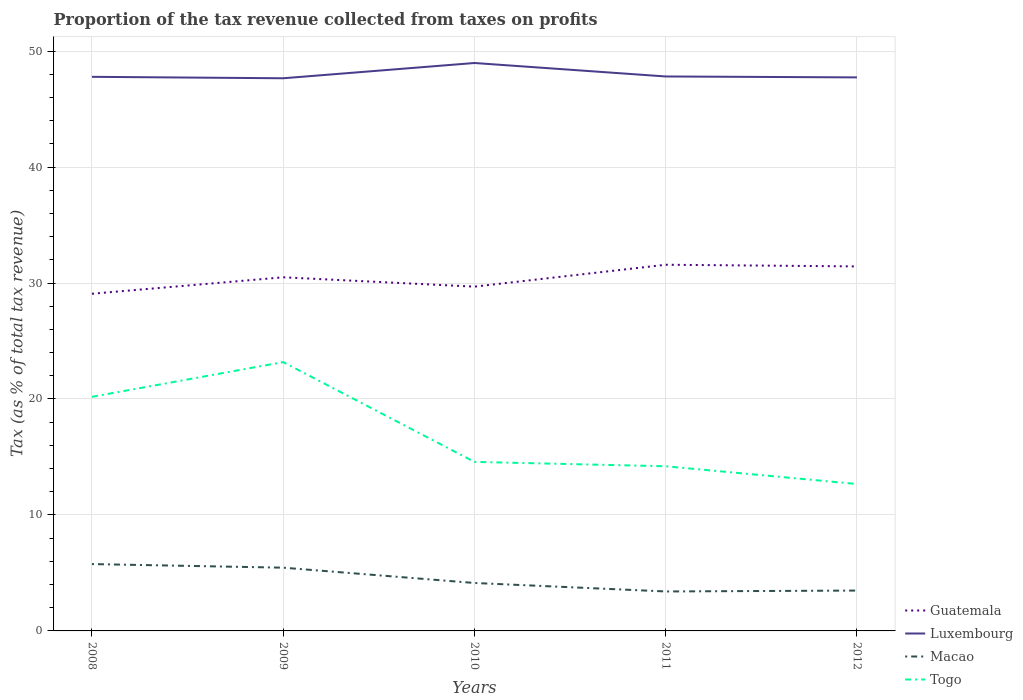Is the number of lines equal to the number of legend labels?
Provide a short and direct response. Yes. Across all years, what is the maximum proportion of the tax revenue collected in Luxembourg?
Provide a succinct answer. 47.66. In which year was the proportion of the tax revenue collected in Guatemala maximum?
Your response must be concise. 2008. What is the total proportion of the tax revenue collected in Togo in the graph?
Your answer should be very brief. 1.91. What is the difference between the highest and the second highest proportion of the tax revenue collected in Guatemala?
Keep it short and to the point. 2.5. Are the values on the major ticks of Y-axis written in scientific E-notation?
Your response must be concise. No. Does the graph contain grids?
Give a very brief answer. Yes. How many legend labels are there?
Provide a succinct answer. 4. What is the title of the graph?
Make the answer very short. Proportion of the tax revenue collected from taxes on profits. What is the label or title of the X-axis?
Provide a short and direct response. Years. What is the label or title of the Y-axis?
Make the answer very short. Tax (as % of total tax revenue). What is the Tax (as % of total tax revenue) in Guatemala in 2008?
Keep it short and to the point. 29.08. What is the Tax (as % of total tax revenue) of Luxembourg in 2008?
Offer a terse response. 47.78. What is the Tax (as % of total tax revenue) of Macao in 2008?
Provide a short and direct response. 5.76. What is the Tax (as % of total tax revenue) of Togo in 2008?
Keep it short and to the point. 20.19. What is the Tax (as % of total tax revenue) in Guatemala in 2009?
Your response must be concise. 30.49. What is the Tax (as % of total tax revenue) of Luxembourg in 2009?
Provide a short and direct response. 47.66. What is the Tax (as % of total tax revenue) of Macao in 2009?
Give a very brief answer. 5.45. What is the Tax (as % of total tax revenue) in Togo in 2009?
Keep it short and to the point. 23.18. What is the Tax (as % of total tax revenue) of Guatemala in 2010?
Your response must be concise. 29.69. What is the Tax (as % of total tax revenue) of Luxembourg in 2010?
Your answer should be very brief. 48.97. What is the Tax (as % of total tax revenue) of Macao in 2010?
Keep it short and to the point. 4.13. What is the Tax (as % of total tax revenue) of Togo in 2010?
Make the answer very short. 14.58. What is the Tax (as % of total tax revenue) of Guatemala in 2011?
Offer a terse response. 31.58. What is the Tax (as % of total tax revenue) of Luxembourg in 2011?
Offer a terse response. 47.81. What is the Tax (as % of total tax revenue) in Macao in 2011?
Provide a short and direct response. 3.4. What is the Tax (as % of total tax revenue) in Togo in 2011?
Your response must be concise. 14.2. What is the Tax (as % of total tax revenue) in Guatemala in 2012?
Your answer should be very brief. 31.43. What is the Tax (as % of total tax revenue) in Luxembourg in 2012?
Offer a terse response. 47.73. What is the Tax (as % of total tax revenue) of Macao in 2012?
Give a very brief answer. 3.48. What is the Tax (as % of total tax revenue) in Togo in 2012?
Your answer should be compact. 12.67. Across all years, what is the maximum Tax (as % of total tax revenue) in Guatemala?
Make the answer very short. 31.58. Across all years, what is the maximum Tax (as % of total tax revenue) in Luxembourg?
Offer a terse response. 48.97. Across all years, what is the maximum Tax (as % of total tax revenue) of Macao?
Make the answer very short. 5.76. Across all years, what is the maximum Tax (as % of total tax revenue) in Togo?
Make the answer very short. 23.18. Across all years, what is the minimum Tax (as % of total tax revenue) in Guatemala?
Provide a short and direct response. 29.08. Across all years, what is the minimum Tax (as % of total tax revenue) of Luxembourg?
Keep it short and to the point. 47.66. Across all years, what is the minimum Tax (as % of total tax revenue) of Macao?
Keep it short and to the point. 3.4. Across all years, what is the minimum Tax (as % of total tax revenue) of Togo?
Ensure brevity in your answer.  12.67. What is the total Tax (as % of total tax revenue) in Guatemala in the graph?
Ensure brevity in your answer.  152.26. What is the total Tax (as % of total tax revenue) of Luxembourg in the graph?
Give a very brief answer. 239.95. What is the total Tax (as % of total tax revenue) in Macao in the graph?
Your response must be concise. 22.23. What is the total Tax (as % of total tax revenue) of Togo in the graph?
Your answer should be compact. 84.81. What is the difference between the Tax (as % of total tax revenue) of Guatemala in 2008 and that in 2009?
Make the answer very short. -1.42. What is the difference between the Tax (as % of total tax revenue) in Luxembourg in 2008 and that in 2009?
Your answer should be compact. 0.12. What is the difference between the Tax (as % of total tax revenue) in Macao in 2008 and that in 2009?
Your response must be concise. 0.31. What is the difference between the Tax (as % of total tax revenue) of Togo in 2008 and that in 2009?
Ensure brevity in your answer.  -2.99. What is the difference between the Tax (as % of total tax revenue) of Guatemala in 2008 and that in 2010?
Your answer should be very brief. -0.61. What is the difference between the Tax (as % of total tax revenue) in Luxembourg in 2008 and that in 2010?
Give a very brief answer. -1.19. What is the difference between the Tax (as % of total tax revenue) of Macao in 2008 and that in 2010?
Your answer should be very brief. 1.63. What is the difference between the Tax (as % of total tax revenue) in Togo in 2008 and that in 2010?
Your answer should be very brief. 5.61. What is the difference between the Tax (as % of total tax revenue) in Luxembourg in 2008 and that in 2011?
Offer a terse response. -0.03. What is the difference between the Tax (as % of total tax revenue) in Macao in 2008 and that in 2011?
Your answer should be very brief. 2.36. What is the difference between the Tax (as % of total tax revenue) in Togo in 2008 and that in 2011?
Give a very brief answer. 5.99. What is the difference between the Tax (as % of total tax revenue) in Guatemala in 2008 and that in 2012?
Make the answer very short. -2.36. What is the difference between the Tax (as % of total tax revenue) of Luxembourg in 2008 and that in 2012?
Give a very brief answer. 0.05. What is the difference between the Tax (as % of total tax revenue) in Macao in 2008 and that in 2012?
Offer a terse response. 2.28. What is the difference between the Tax (as % of total tax revenue) in Togo in 2008 and that in 2012?
Ensure brevity in your answer.  7.52. What is the difference between the Tax (as % of total tax revenue) in Guatemala in 2009 and that in 2010?
Your response must be concise. 0.81. What is the difference between the Tax (as % of total tax revenue) of Luxembourg in 2009 and that in 2010?
Keep it short and to the point. -1.32. What is the difference between the Tax (as % of total tax revenue) of Macao in 2009 and that in 2010?
Your answer should be very brief. 1.32. What is the difference between the Tax (as % of total tax revenue) of Togo in 2009 and that in 2010?
Your answer should be compact. 8.61. What is the difference between the Tax (as % of total tax revenue) in Guatemala in 2009 and that in 2011?
Your response must be concise. -1.08. What is the difference between the Tax (as % of total tax revenue) in Luxembourg in 2009 and that in 2011?
Provide a succinct answer. -0.15. What is the difference between the Tax (as % of total tax revenue) of Macao in 2009 and that in 2011?
Your response must be concise. 2.05. What is the difference between the Tax (as % of total tax revenue) of Togo in 2009 and that in 2011?
Ensure brevity in your answer.  8.98. What is the difference between the Tax (as % of total tax revenue) of Guatemala in 2009 and that in 2012?
Keep it short and to the point. -0.94. What is the difference between the Tax (as % of total tax revenue) in Luxembourg in 2009 and that in 2012?
Offer a terse response. -0.08. What is the difference between the Tax (as % of total tax revenue) of Macao in 2009 and that in 2012?
Provide a succinct answer. 1.97. What is the difference between the Tax (as % of total tax revenue) of Togo in 2009 and that in 2012?
Provide a succinct answer. 10.51. What is the difference between the Tax (as % of total tax revenue) of Guatemala in 2010 and that in 2011?
Ensure brevity in your answer.  -1.89. What is the difference between the Tax (as % of total tax revenue) of Luxembourg in 2010 and that in 2011?
Make the answer very short. 1.16. What is the difference between the Tax (as % of total tax revenue) of Macao in 2010 and that in 2011?
Your response must be concise. 0.73. What is the difference between the Tax (as % of total tax revenue) in Togo in 2010 and that in 2011?
Your response must be concise. 0.38. What is the difference between the Tax (as % of total tax revenue) of Guatemala in 2010 and that in 2012?
Your answer should be compact. -1.74. What is the difference between the Tax (as % of total tax revenue) in Luxembourg in 2010 and that in 2012?
Your response must be concise. 1.24. What is the difference between the Tax (as % of total tax revenue) of Macao in 2010 and that in 2012?
Your answer should be very brief. 0.65. What is the difference between the Tax (as % of total tax revenue) in Togo in 2010 and that in 2012?
Provide a succinct answer. 1.91. What is the difference between the Tax (as % of total tax revenue) of Guatemala in 2011 and that in 2012?
Ensure brevity in your answer.  0.14. What is the difference between the Tax (as % of total tax revenue) in Luxembourg in 2011 and that in 2012?
Provide a succinct answer. 0.08. What is the difference between the Tax (as % of total tax revenue) of Macao in 2011 and that in 2012?
Keep it short and to the point. -0.08. What is the difference between the Tax (as % of total tax revenue) in Togo in 2011 and that in 2012?
Your answer should be compact. 1.53. What is the difference between the Tax (as % of total tax revenue) in Guatemala in 2008 and the Tax (as % of total tax revenue) in Luxembourg in 2009?
Make the answer very short. -18.58. What is the difference between the Tax (as % of total tax revenue) in Guatemala in 2008 and the Tax (as % of total tax revenue) in Macao in 2009?
Provide a short and direct response. 23.62. What is the difference between the Tax (as % of total tax revenue) of Guatemala in 2008 and the Tax (as % of total tax revenue) of Togo in 2009?
Provide a succinct answer. 5.89. What is the difference between the Tax (as % of total tax revenue) in Luxembourg in 2008 and the Tax (as % of total tax revenue) in Macao in 2009?
Provide a short and direct response. 42.33. What is the difference between the Tax (as % of total tax revenue) in Luxembourg in 2008 and the Tax (as % of total tax revenue) in Togo in 2009?
Your answer should be very brief. 24.6. What is the difference between the Tax (as % of total tax revenue) of Macao in 2008 and the Tax (as % of total tax revenue) of Togo in 2009?
Your answer should be compact. -17.42. What is the difference between the Tax (as % of total tax revenue) of Guatemala in 2008 and the Tax (as % of total tax revenue) of Luxembourg in 2010?
Ensure brevity in your answer.  -19.9. What is the difference between the Tax (as % of total tax revenue) in Guatemala in 2008 and the Tax (as % of total tax revenue) in Macao in 2010?
Ensure brevity in your answer.  24.94. What is the difference between the Tax (as % of total tax revenue) in Guatemala in 2008 and the Tax (as % of total tax revenue) in Togo in 2010?
Provide a short and direct response. 14.5. What is the difference between the Tax (as % of total tax revenue) of Luxembourg in 2008 and the Tax (as % of total tax revenue) of Macao in 2010?
Your answer should be very brief. 43.65. What is the difference between the Tax (as % of total tax revenue) in Luxembourg in 2008 and the Tax (as % of total tax revenue) in Togo in 2010?
Provide a short and direct response. 33.2. What is the difference between the Tax (as % of total tax revenue) of Macao in 2008 and the Tax (as % of total tax revenue) of Togo in 2010?
Make the answer very short. -8.81. What is the difference between the Tax (as % of total tax revenue) of Guatemala in 2008 and the Tax (as % of total tax revenue) of Luxembourg in 2011?
Ensure brevity in your answer.  -18.73. What is the difference between the Tax (as % of total tax revenue) of Guatemala in 2008 and the Tax (as % of total tax revenue) of Macao in 2011?
Offer a very short reply. 25.67. What is the difference between the Tax (as % of total tax revenue) of Guatemala in 2008 and the Tax (as % of total tax revenue) of Togo in 2011?
Your response must be concise. 14.88. What is the difference between the Tax (as % of total tax revenue) in Luxembourg in 2008 and the Tax (as % of total tax revenue) in Macao in 2011?
Provide a short and direct response. 44.38. What is the difference between the Tax (as % of total tax revenue) of Luxembourg in 2008 and the Tax (as % of total tax revenue) of Togo in 2011?
Offer a very short reply. 33.58. What is the difference between the Tax (as % of total tax revenue) in Macao in 2008 and the Tax (as % of total tax revenue) in Togo in 2011?
Your response must be concise. -8.43. What is the difference between the Tax (as % of total tax revenue) in Guatemala in 2008 and the Tax (as % of total tax revenue) in Luxembourg in 2012?
Give a very brief answer. -18.66. What is the difference between the Tax (as % of total tax revenue) in Guatemala in 2008 and the Tax (as % of total tax revenue) in Macao in 2012?
Make the answer very short. 25.6. What is the difference between the Tax (as % of total tax revenue) in Guatemala in 2008 and the Tax (as % of total tax revenue) in Togo in 2012?
Ensure brevity in your answer.  16.41. What is the difference between the Tax (as % of total tax revenue) of Luxembourg in 2008 and the Tax (as % of total tax revenue) of Macao in 2012?
Give a very brief answer. 44.3. What is the difference between the Tax (as % of total tax revenue) of Luxembourg in 2008 and the Tax (as % of total tax revenue) of Togo in 2012?
Give a very brief answer. 35.11. What is the difference between the Tax (as % of total tax revenue) in Macao in 2008 and the Tax (as % of total tax revenue) in Togo in 2012?
Offer a terse response. -6.9. What is the difference between the Tax (as % of total tax revenue) in Guatemala in 2009 and the Tax (as % of total tax revenue) in Luxembourg in 2010?
Your response must be concise. -18.48. What is the difference between the Tax (as % of total tax revenue) of Guatemala in 2009 and the Tax (as % of total tax revenue) of Macao in 2010?
Provide a short and direct response. 26.36. What is the difference between the Tax (as % of total tax revenue) of Guatemala in 2009 and the Tax (as % of total tax revenue) of Togo in 2010?
Offer a terse response. 15.92. What is the difference between the Tax (as % of total tax revenue) in Luxembourg in 2009 and the Tax (as % of total tax revenue) in Macao in 2010?
Keep it short and to the point. 43.52. What is the difference between the Tax (as % of total tax revenue) of Luxembourg in 2009 and the Tax (as % of total tax revenue) of Togo in 2010?
Keep it short and to the point. 33.08. What is the difference between the Tax (as % of total tax revenue) in Macao in 2009 and the Tax (as % of total tax revenue) in Togo in 2010?
Offer a very short reply. -9.12. What is the difference between the Tax (as % of total tax revenue) of Guatemala in 2009 and the Tax (as % of total tax revenue) of Luxembourg in 2011?
Ensure brevity in your answer.  -17.32. What is the difference between the Tax (as % of total tax revenue) in Guatemala in 2009 and the Tax (as % of total tax revenue) in Macao in 2011?
Provide a succinct answer. 27.09. What is the difference between the Tax (as % of total tax revenue) of Guatemala in 2009 and the Tax (as % of total tax revenue) of Togo in 2011?
Offer a very short reply. 16.29. What is the difference between the Tax (as % of total tax revenue) of Luxembourg in 2009 and the Tax (as % of total tax revenue) of Macao in 2011?
Ensure brevity in your answer.  44.25. What is the difference between the Tax (as % of total tax revenue) of Luxembourg in 2009 and the Tax (as % of total tax revenue) of Togo in 2011?
Provide a short and direct response. 33.46. What is the difference between the Tax (as % of total tax revenue) of Macao in 2009 and the Tax (as % of total tax revenue) of Togo in 2011?
Ensure brevity in your answer.  -8.74. What is the difference between the Tax (as % of total tax revenue) of Guatemala in 2009 and the Tax (as % of total tax revenue) of Luxembourg in 2012?
Your response must be concise. -17.24. What is the difference between the Tax (as % of total tax revenue) of Guatemala in 2009 and the Tax (as % of total tax revenue) of Macao in 2012?
Provide a succinct answer. 27.01. What is the difference between the Tax (as % of total tax revenue) of Guatemala in 2009 and the Tax (as % of total tax revenue) of Togo in 2012?
Keep it short and to the point. 17.82. What is the difference between the Tax (as % of total tax revenue) in Luxembourg in 2009 and the Tax (as % of total tax revenue) in Macao in 2012?
Keep it short and to the point. 44.18. What is the difference between the Tax (as % of total tax revenue) in Luxembourg in 2009 and the Tax (as % of total tax revenue) in Togo in 2012?
Provide a short and direct response. 34.99. What is the difference between the Tax (as % of total tax revenue) in Macao in 2009 and the Tax (as % of total tax revenue) in Togo in 2012?
Provide a short and direct response. -7.22. What is the difference between the Tax (as % of total tax revenue) in Guatemala in 2010 and the Tax (as % of total tax revenue) in Luxembourg in 2011?
Ensure brevity in your answer.  -18.12. What is the difference between the Tax (as % of total tax revenue) of Guatemala in 2010 and the Tax (as % of total tax revenue) of Macao in 2011?
Give a very brief answer. 26.29. What is the difference between the Tax (as % of total tax revenue) in Guatemala in 2010 and the Tax (as % of total tax revenue) in Togo in 2011?
Offer a very short reply. 15.49. What is the difference between the Tax (as % of total tax revenue) of Luxembourg in 2010 and the Tax (as % of total tax revenue) of Macao in 2011?
Ensure brevity in your answer.  45.57. What is the difference between the Tax (as % of total tax revenue) in Luxembourg in 2010 and the Tax (as % of total tax revenue) in Togo in 2011?
Make the answer very short. 34.77. What is the difference between the Tax (as % of total tax revenue) of Macao in 2010 and the Tax (as % of total tax revenue) of Togo in 2011?
Your answer should be compact. -10.06. What is the difference between the Tax (as % of total tax revenue) of Guatemala in 2010 and the Tax (as % of total tax revenue) of Luxembourg in 2012?
Provide a succinct answer. -18.04. What is the difference between the Tax (as % of total tax revenue) of Guatemala in 2010 and the Tax (as % of total tax revenue) of Macao in 2012?
Provide a short and direct response. 26.21. What is the difference between the Tax (as % of total tax revenue) in Guatemala in 2010 and the Tax (as % of total tax revenue) in Togo in 2012?
Ensure brevity in your answer.  17.02. What is the difference between the Tax (as % of total tax revenue) in Luxembourg in 2010 and the Tax (as % of total tax revenue) in Macao in 2012?
Offer a very short reply. 45.49. What is the difference between the Tax (as % of total tax revenue) of Luxembourg in 2010 and the Tax (as % of total tax revenue) of Togo in 2012?
Offer a very short reply. 36.3. What is the difference between the Tax (as % of total tax revenue) of Macao in 2010 and the Tax (as % of total tax revenue) of Togo in 2012?
Offer a terse response. -8.53. What is the difference between the Tax (as % of total tax revenue) in Guatemala in 2011 and the Tax (as % of total tax revenue) in Luxembourg in 2012?
Your answer should be compact. -16.16. What is the difference between the Tax (as % of total tax revenue) of Guatemala in 2011 and the Tax (as % of total tax revenue) of Macao in 2012?
Offer a very short reply. 28.1. What is the difference between the Tax (as % of total tax revenue) in Guatemala in 2011 and the Tax (as % of total tax revenue) in Togo in 2012?
Offer a very short reply. 18.91. What is the difference between the Tax (as % of total tax revenue) of Luxembourg in 2011 and the Tax (as % of total tax revenue) of Macao in 2012?
Make the answer very short. 44.33. What is the difference between the Tax (as % of total tax revenue) in Luxembourg in 2011 and the Tax (as % of total tax revenue) in Togo in 2012?
Make the answer very short. 35.14. What is the difference between the Tax (as % of total tax revenue) in Macao in 2011 and the Tax (as % of total tax revenue) in Togo in 2012?
Provide a short and direct response. -9.27. What is the average Tax (as % of total tax revenue) in Guatemala per year?
Offer a very short reply. 30.45. What is the average Tax (as % of total tax revenue) of Luxembourg per year?
Offer a terse response. 47.99. What is the average Tax (as % of total tax revenue) of Macao per year?
Offer a terse response. 4.45. What is the average Tax (as % of total tax revenue) in Togo per year?
Make the answer very short. 16.96. In the year 2008, what is the difference between the Tax (as % of total tax revenue) of Guatemala and Tax (as % of total tax revenue) of Luxembourg?
Ensure brevity in your answer.  -18.7. In the year 2008, what is the difference between the Tax (as % of total tax revenue) in Guatemala and Tax (as % of total tax revenue) in Macao?
Give a very brief answer. 23.31. In the year 2008, what is the difference between the Tax (as % of total tax revenue) in Guatemala and Tax (as % of total tax revenue) in Togo?
Your answer should be compact. 8.89. In the year 2008, what is the difference between the Tax (as % of total tax revenue) of Luxembourg and Tax (as % of total tax revenue) of Macao?
Ensure brevity in your answer.  42.02. In the year 2008, what is the difference between the Tax (as % of total tax revenue) in Luxembourg and Tax (as % of total tax revenue) in Togo?
Ensure brevity in your answer.  27.59. In the year 2008, what is the difference between the Tax (as % of total tax revenue) of Macao and Tax (as % of total tax revenue) of Togo?
Provide a succinct answer. -14.42. In the year 2009, what is the difference between the Tax (as % of total tax revenue) of Guatemala and Tax (as % of total tax revenue) of Luxembourg?
Your answer should be compact. -17.16. In the year 2009, what is the difference between the Tax (as % of total tax revenue) in Guatemala and Tax (as % of total tax revenue) in Macao?
Keep it short and to the point. 25.04. In the year 2009, what is the difference between the Tax (as % of total tax revenue) of Guatemala and Tax (as % of total tax revenue) of Togo?
Ensure brevity in your answer.  7.31. In the year 2009, what is the difference between the Tax (as % of total tax revenue) in Luxembourg and Tax (as % of total tax revenue) in Macao?
Make the answer very short. 42.2. In the year 2009, what is the difference between the Tax (as % of total tax revenue) in Luxembourg and Tax (as % of total tax revenue) in Togo?
Provide a succinct answer. 24.47. In the year 2009, what is the difference between the Tax (as % of total tax revenue) of Macao and Tax (as % of total tax revenue) of Togo?
Keep it short and to the point. -17.73. In the year 2010, what is the difference between the Tax (as % of total tax revenue) in Guatemala and Tax (as % of total tax revenue) in Luxembourg?
Your answer should be very brief. -19.28. In the year 2010, what is the difference between the Tax (as % of total tax revenue) of Guatemala and Tax (as % of total tax revenue) of Macao?
Offer a terse response. 25.55. In the year 2010, what is the difference between the Tax (as % of total tax revenue) of Guatemala and Tax (as % of total tax revenue) of Togo?
Offer a very short reply. 15.11. In the year 2010, what is the difference between the Tax (as % of total tax revenue) in Luxembourg and Tax (as % of total tax revenue) in Macao?
Provide a short and direct response. 44.84. In the year 2010, what is the difference between the Tax (as % of total tax revenue) in Luxembourg and Tax (as % of total tax revenue) in Togo?
Your answer should be compact. 34.4. In the year 2010, what is the difference between the Tax (as % of total tax revenue) in Macao and Tax (as % of total tax revenue) in Togo?
Provide a short and direct response. -10.44. In the year 2011, what is the difference between the Tax (as % of total tax revenue) of Guatemala and Tax (as % of total tax revenue) of Luxembourg?
Provide a succinct answer. -16.23. In the year 2011, what is the difference between the Tax (as % of total tax revenue) of Guatemala and Tax (as % of total tax revenue) of Macao?
Give a very brief answer. 28.17. In the year 2011, what is the difference between the Tax (as % of total tax revenue) in Guatemala and Tax (as % of total tax revenue) in Togo?
Make the answer very short. 17.38. In the year 2011, what is the difference between the Tax (as % of total tax revenue) in Luxembourg and Tax (as % of total tax revenue) in Macao?
Keep it short and to the point. 44.41. In the year 2011, what is the difference between the Tax (as % of total tax revenue) in Luxembourg and Tax (as % of total tax revenue) in Togo?
Give a very brief answer. 33.61. In the year 2011, what is the difference between the Tax (as % of total tax revenue) of Macao and Tax (as % of total tax revenue) of Togo?
Make the answer very short. -10.8. In the year 2012, what is the difference between the Tax (as % of total tax revenue) of Guatemala and Tax (as % of total tax revenue) of Luxembourg?
Your response must be concise. -16.3. In the year 2012, what is the difference between the Tax (as % of total tax revenue) of Guatemala and Tax (as % of total tax revenue) of Macao?
Provide a succinct answer. 27.95. In the year 2012, what is the difference between the Tax (as % of total tax revenue) in Guatemala and Tax (as % of total tax revenue) in Togo?
Offer a terse response. 18.76. In the year 2012, what is the difference between the Tax (as % of total tax revenue) of Luxembourg and Tax (as % of total tax revenue) of Macao?
Your response must be concise. 44.25. In the year 2012, what is the difference between the Tax (as % of total tax revenue) in Luxembourg and Tax (as % of total tax revenue) in Togo?
Provide a succinct answer. 35.06. In the year 2012, what is the difference between the Tax (as % of total tax revenue) in Macao and Tax (as % of total tax revenue) in Togo?
Your answer should be very brief. -9.19. What is the ratio of the Tax (as % of total tax revenue) of Guatemala in 2008 to that in 2009?
Provide a succinct answer. 0.95. What is the ratio of the Tax (as % of total tax revenue) in Luxembourg in 2008 to that in 2009?
Offer a terse response. 1. What is the ratio of the Tax (as % of total tax revenue) of Macao in 2008 to that in 2009?
Your answer should be very brief. 1.06. What is the ratio of the Tax (as % of total tax revenue) in Togo in 2008 to that in 2009?
Give a very brief answer. 0.87. What is the ratio of the Tax (as % of total tax revenue) of Guatemala in 2008 to that in 2010?
Provide a short and direct response. 0.98. What is the ratio of the Tax (as % of total tax revenue) of Luxembourg in 2008 to that in 2010?
Your answer should be compact. 0.98. What is the ratio of the Tax (as % of total tax revenue) of Macao in 2008 to that in 2010?
Make the answer very short. 1.39. What is the ratio of the Tax (as % of total tax revenue) in Togo in 2008 to that in 2010?
Your answer should be very brief. 1.38. What is the ratio of the Tax (as % of total tax revenue) of Guatemala in 2008 to that in 2011?
Your answer should be very brief. 0.92. What is the ratio of the Tax (as % of total tax revenue) in Luxembourg in 2008 to that in 2011?
Provide a succinct answer. 1. What is the ratio of the Tax (as % of total tax revenue) in Macao in 2008 to that in 2011?
Offer a very short reply. 1.69. What is the ratio of the Tax (as % of total tax revenue) in Togo in 2008 to that in 2011?
Ensure brevity in your answer.  1.42. What is the ratio of the Tax (as % of total tax revenue) in Guatemala in 2008 to that in 2012?
Your answer should be very brief. 0.93. What is the ratio of the Tax (as % of total tax revenue) in Macao in 2008 to that in 2012?
Your answer should be very brief. 1.66. What is the ratio of the Tax (as % of total tax revenue) in Togo in 2008 to that in 2012?
Keep it short and to the point. 1.59. What is the ratio of the Tax (as % of total tax revenue) in Guatemala in 2009 to that in 2010?
Provide a succinct answer. 1.03. What is the ratio of the Tax (as % of total tax revenue) of Luxembourg in 2009 to that in 2010?
Keep it short and to the point. 0.97. What is the ratio of the Tax (as % of total tax revenue) in Macao in 2009 to that in 2010?
Provide a short and direct response. 1.32. What is the ratio of the Tax (as % of total tax revenue) of Togo in 2009 to that in 2010?
Your answer should be very brief. 1.59. What is the ratio of the Tax (as % of total tax revenue) in Guatemala in 2009 to that in 2011?
Give a very brief answer. 0.97. What is the ratio of the Tax (as % of total tax revenue) of Macao in 2009 to that in 2011?
Offer a terse response. 1.6. What is the ratio of the Tax (as % of total tax revenue) in Togo in 2009 to that in 2011?
Ensure brevity in your answer.  1.63. What is the ratio of the Tax (as % of total tax revenue) of Guatemala in 2009 to that in 2012?
Your answer should be compact. 0.97. What is the ratio of the Tax (as % of total tax revenue) in Luxembourg in 2009 to that in 2012?
Your answer should be compact. 1. What is the ratio of the Tax (as % of total tax revenue) of Macao in 2009 to that in 2012?
Your response must be concise. 1.57. What is the ratio of the Tax (as % of total tax revenue) in Togo in 2009 to that in 2012?
Your answer should be very brief. 1.83. What is the ratio of the Tax (as % of total tax revenue) in Guatemala in 2010 to that in 2011?
Keep it short and to the point. 0.94. What is the ratio of the Tax (as % of total tax revenue) of Luxembourg in 2010 to that in 2011?
Give a very brief answer. 1.02. What is the ratio of the Tax (as % of total tax revenue) in Macao in 2010 to that in 2011?
Provide a short and direct response. 1.22. What is the ratio of the Tax (as % of total tax revenue) in Togo in 2010 to that in 2011?
Offer a terse response. 1.03. What is the ratio of the Tax (as % of total tax revenue) of Guatemala in 2010 to that in 2012?
Your answer should be very brief. 0.94. What is the ratio of the Tax (as % of total tax revenue) of Luxembourg in 2010 to that in 2012?
Ensure brevity in your answer.  1.03. What is the ratio of the Tax (as % of total tax revenue) of Macao in 2010 to that in 2012?
Your answer should be compact. 1.19. What is the ratio of the Tax (as % of total tax revenue) in Togo in 2010 to that in 2012?
Ensure brevity in your answer.  1.15. What is the ratio of the Tax (as % of total tax revenue) in Luxembourg in 2011 to that in 2012?
Offer a very short reply. 1. What is the ratio of the Tax (as % of total tax revenue) in Macao in 2011 to that in 2012?
Your answer should be very brief. 0.98. What is the ratio of the Tax (as % of total tax revenue) of Togo in 2011 to that in 2012?
Provide a short and direct response. 1.12. What is the difference between the highest and the second highest Tax (as % of total tax revenue) of Guatemala?
Your answer should be compact. 0.14. What is the difference between the highest and the second highest Tax (as % of total tax revenue) in Luxembourg?
Give a very brief answer. 1.16. What is the difference between the highest and the second highest Tax (as % of total tax revenue) in Macao?
Offer a very short reply. 0.31. What is the difference between the highest and the second highest Tax (as % of total tax revenue) in Togo?
Your answer should be compact. 2.99. What is the difference between the highest and the lowest Tax (as % of total tax revenue) in Luxembourg?
Your answer should be very brief. 1.32. What is the difference between the highest and the lowest Tax (as % of total tax revenue) in Macao?
Provide a succinct answer. 2.36. What is the difference between the highest and the lowest Tax (as % of total tax revenue) in Togo?
Give a very brief answer. 10.51. 